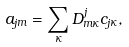Convert formula to latex. <formula><loc_0><loc_0><loc_500><loc_500>a _ { j m } = \sum _ { \kappa } D _ { m \kappa } ^ { j } c _ { j \kappa } ,</formula> 